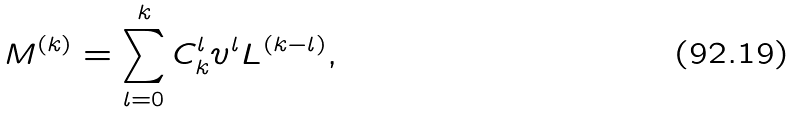<formula> <loc_0><loc_0><loc_500><loc_500>M ^ { ( k ) } = \sum _ { l = 0 } ^ { k } C _ { k } ^ { l } v ^ { l } L ^ { ( k - l ) } ,</formula> 